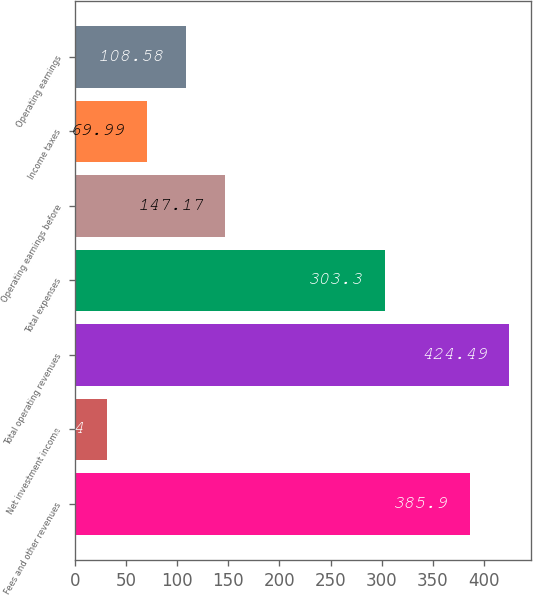Convert chart. <chart><loc_0><loc_0><loc_500><loc_500><bar_chart><fcel>Fees and other revenues<fcel>Net investment income<fcel>Total operating revenues<fcel>Total expenses<fcel>Operating earnings before<fcel>Income taxes<fcel>Operating earnings<nl><fcel>385.9<fcel>31.4<fcel>424.49<fcel>303.3<fcel>147.17<fcel>69.99<fcel>108.58<nl></chart> 